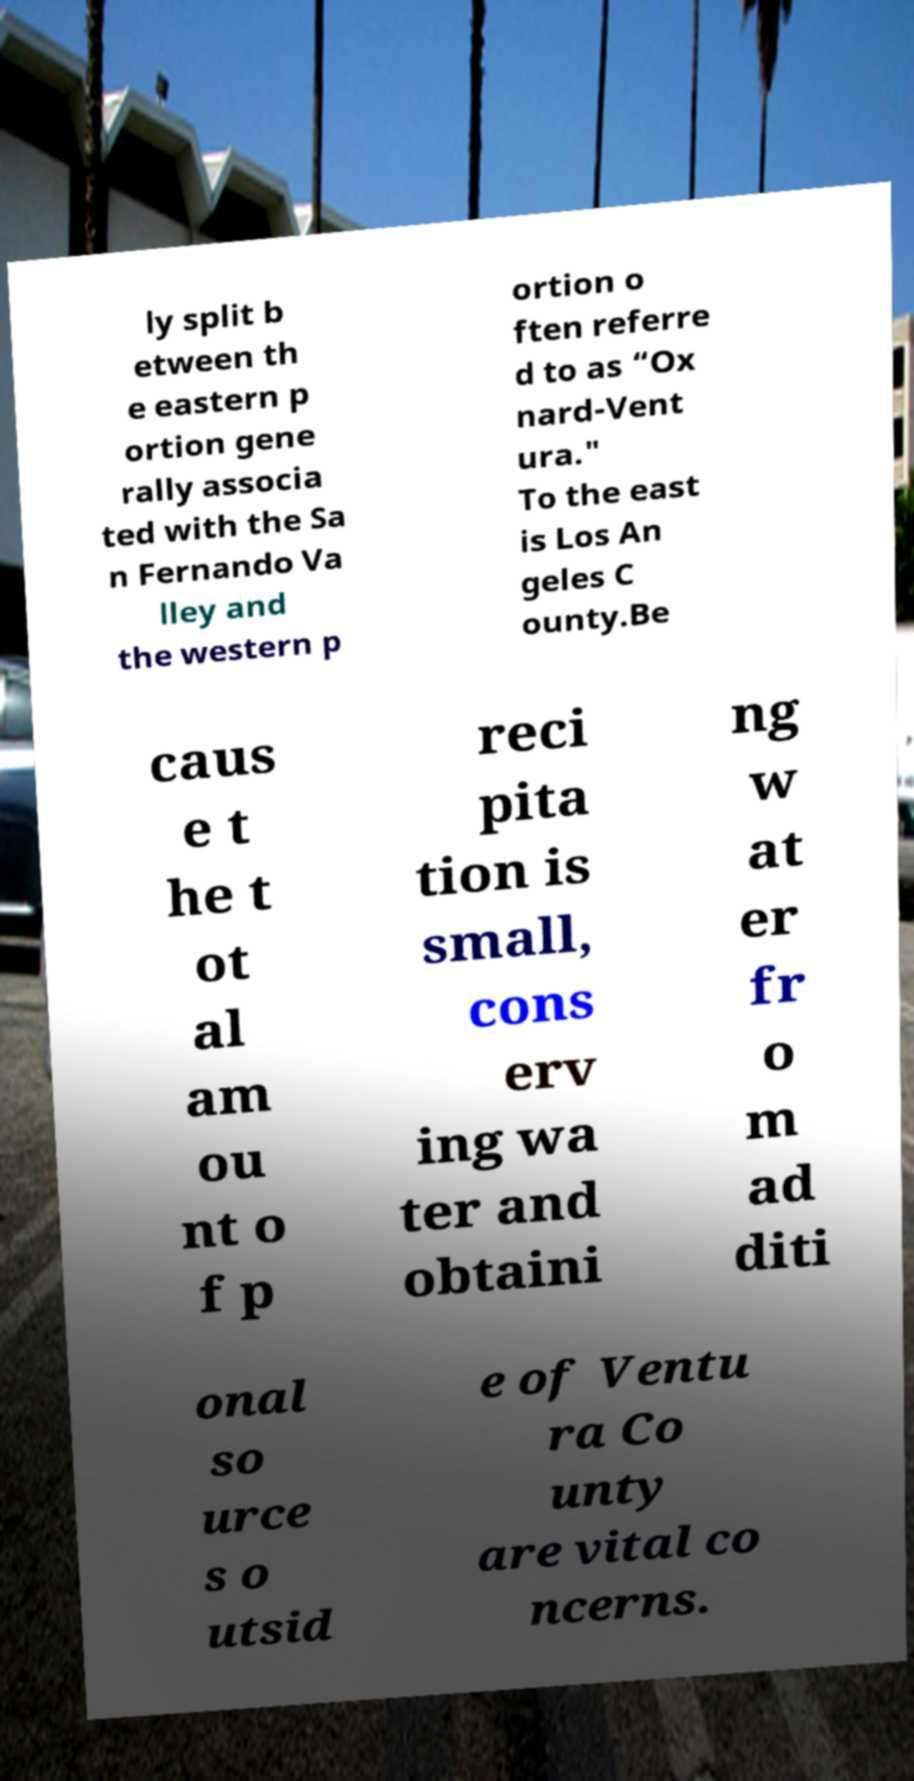Please read and relay the text visible in this image. What does it say? ly split b etween th e eastern p ortion gene rally associa ted with the Sa n Fernando Va lley and the western p ortion o ften referre d to as “Ox nard-Vent ura." To the east is Los An geles C ounty.Be caus e t he t ot al am ou nt o f p reci pita tion is small, cons erv ing wa ter and obtaini ng w at er fr o m ad diti onal so urce s o utsid e of Ventu ra Co unty are vital co ncerns. 